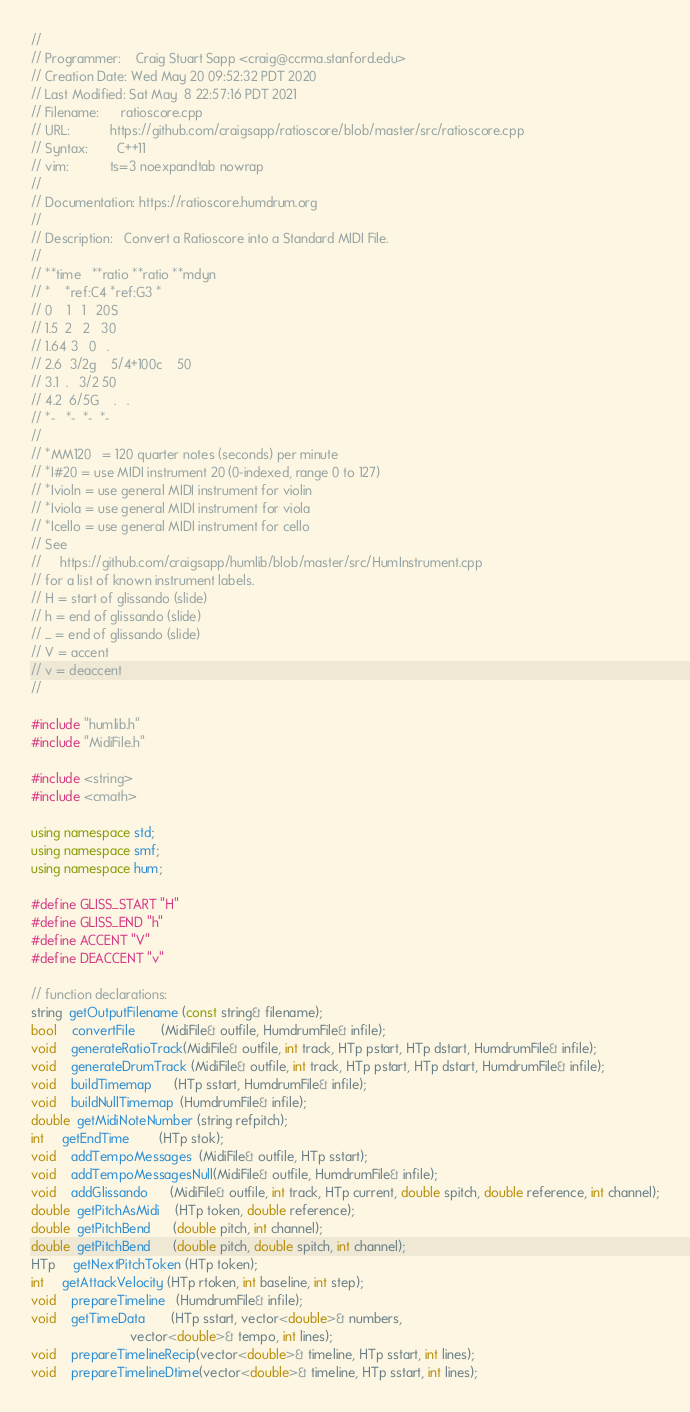Convert code to text. <code><loc_0><loc_0><loc_500><loc_500><_C++_>//
// Programmer:    Craig Stuart Sapp <craig@ccrma.stanford.edu>
// Creation Date: Wed May 20 09:52:32 PDT 2020
// Last Modified: Sat May  8 22:57:16 PDT 2021
// Filename:      ratioscore.cpp
// URL:           https://github.com/craigsapp/ratioscore/blob/master/src/ratioscore.cpp
// Syntax:        C++11
// vim:           ts=3 noexpandtab nowrap
//
// Documentation: https://ratioscore.humdrum.org
//
// Description:   Convert a Ratioscore into a Standard MIDI File.
//
// **time	**ratio	**ratio	**mdyn
// *	*ref:C4	*ref:G3	*
// 0	1	1	20S
// 1.5	2	2	30
// 1.64	3	0	.
// 2.6	3/2g	5/4+100c	50
// 3.1	.	3/2	50
// 4.2	6/5G	.	.
// *-	*-	*-	*-
//
// *MM120   = 120 quarter notes (seconds) per minute
// *I#20 = use MIDI instrument 20 (0-indexed, range 0 to 127)
// *Ivioln = use general MIDI instrument for violin
// *Iviola = use general MIDI instrument for viola
// *Icello = use general MIDI instrument for cello
// See
//     https://github.com/craigsapp/humlib/blob/master/src/HumInstrument.cpp
// for a list of known instrument labels.
// H = start of glissando (slide)
// h = end of glissando (slide)
// _ = end of glissando (slide)
// V = accent
// v = deaccent
//

#include "humlib.h"
#include "MidiFile.h"

#include <string>
#include <cmath>

using namespace std;
using namespace smf;
using namespace hum;

#define GLISS_START "H"
#define GLISS_END "h"
#define ACCENT "V"
#define DEACCENT "v"

// function declarations:
string  getOutputFilename (const string& filename);
bool    convertFile       (MidiFile& outfile, HumdrumFile& infile);
void    generateRatioTrack(MidiFile& outfile, int track, HTp pstart, HTp dstart, HumdrumFile& infile);
void    generateDrumTrack (MidiFile& outfile, int track, HTp pstart, HTp dstart, HumdrumFile& infile);
void    buildTimemap      (HTp sstart, HumdrumFile& infile);
void    buildNullTimemap  (HumdrumFile& infile);
double  getMidiNoteNumber (string refpitch);
int     getEndTime        (HTp stok);
void    addTempoMessages  (MidiFile& outfile, HTp sstart);
void    addTempoMessagesNull(MidiFile& outfile, HumdrumFile& infile);
void    addGlissando      (MidiFile& outfile, int track, HTp current, double spitch, double reference, int channel);
double  getPitchAsMidi    (HTp token, double reference);
double  getPitchBend      (double pitch, int channel);
double  getPitchBend      (double pitch, double spitch, int channel);
HTp     getNextPitchToken (HTp token);
int     getAttackVelocity (HTp rtoken, int baseline, int step);
void    prepareTimeline   (HumdrumFile& infile);
void    getTimeData       (HTp sstart, vector<double>& numbers,
                           vector<double>& tempo, int lines);
void    prepareTimelineRecip(vector<double>& timeline, HTp sstart, int lines);
void    prepareTimelineDtime(vector<double>& timeline, HTp sstart, int lines);</code> 